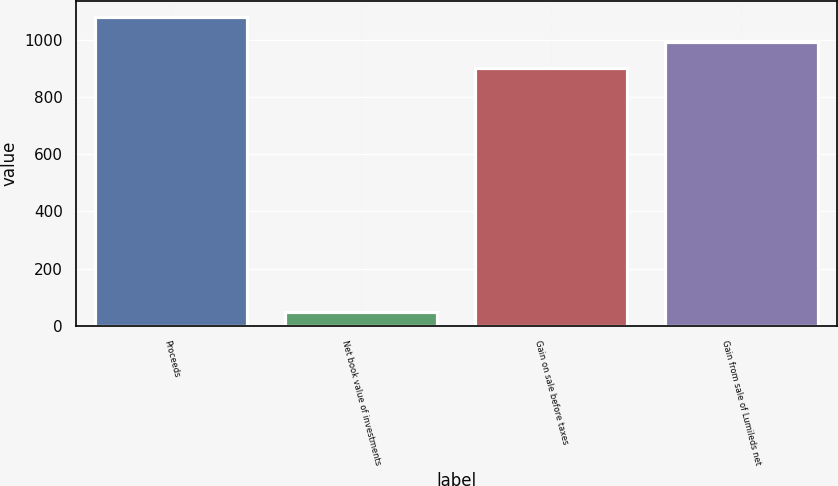Convert chart to OTSL. <chart><loc_0><loc_0><loc_500><loc_500><bar_chart><fcel>Proceeds<fcel>Net book value of investments<fcel>Gain on sale before taxes<fcel>Gain from sale of Lumileds net<nl><fcel>1081.2<fcel>48<fcel>901<fcel>991.1<nl></chart> 